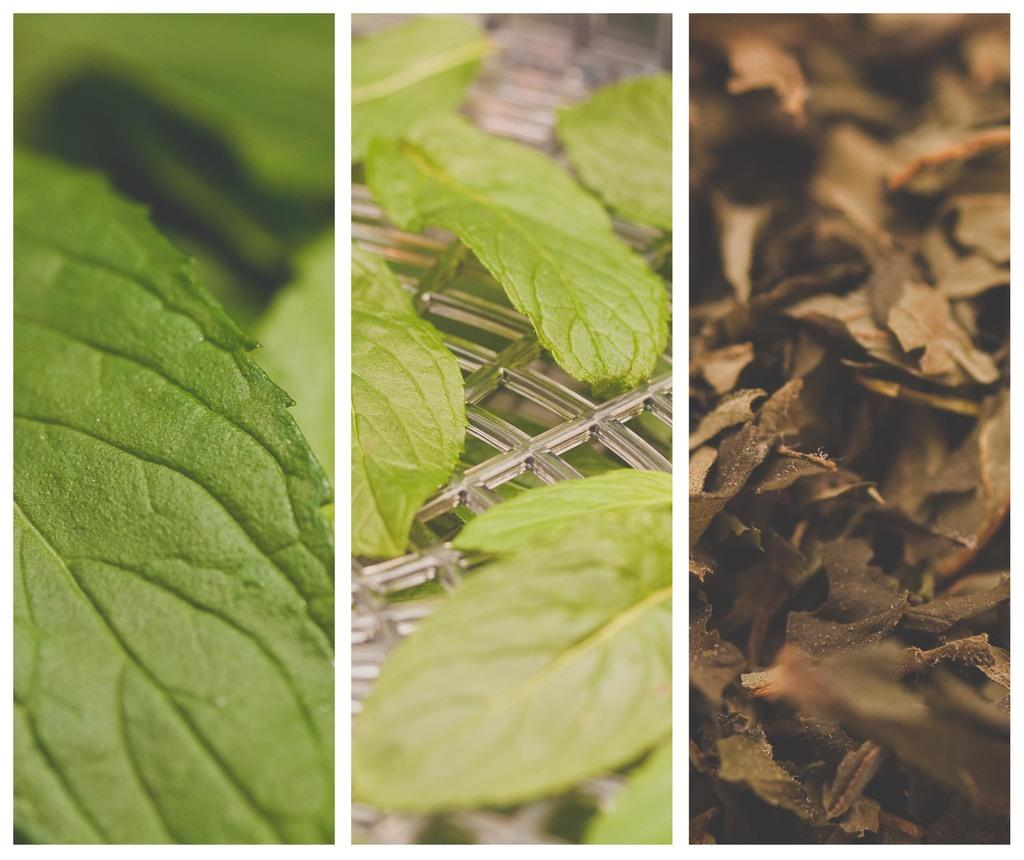What type of artwork is the image in question? The image is a collage. What subject matter is featured in the collage? There are three different images of leaves in the collage. What type of meal is being prepared in the image? There is no meal being prepared in the image, as it is a collage featuring images of leaves. Can you describe any criminal activity taking place in the image? There is no criminal activity depicted in the image, as it is a collage featuring images of leaves. 